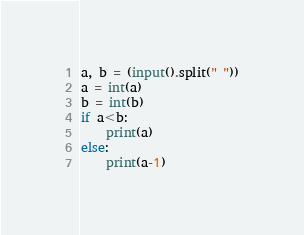<code> <loc_0><loc_0><loc_500><loc_500><_Python_>a, b = (input().split(" "))
a = int(a)
b = int(b)
if a<b:
    print(a)
else:
    print(a-1)</code> 